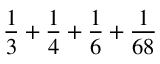<formula> <loc_0><loc_0><loc_500><loc_500>{ \frac { 1 } { 3 } } + { \frac { 1 } { 4 } } + { \frac { 1 } { 6 } } + { \frac { 1 } { 6 8 } }</formula> 